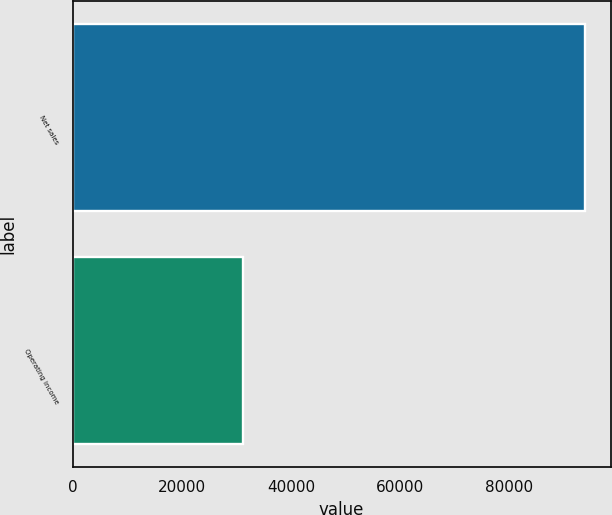Convert chart to OTSL. <chart><loc_0><loc_0><loc_500><loc_500><bar_chart><fcel>Net sales<fcel>Operating income<nl><fcel>93864<fcel>31186<nl></chart> 